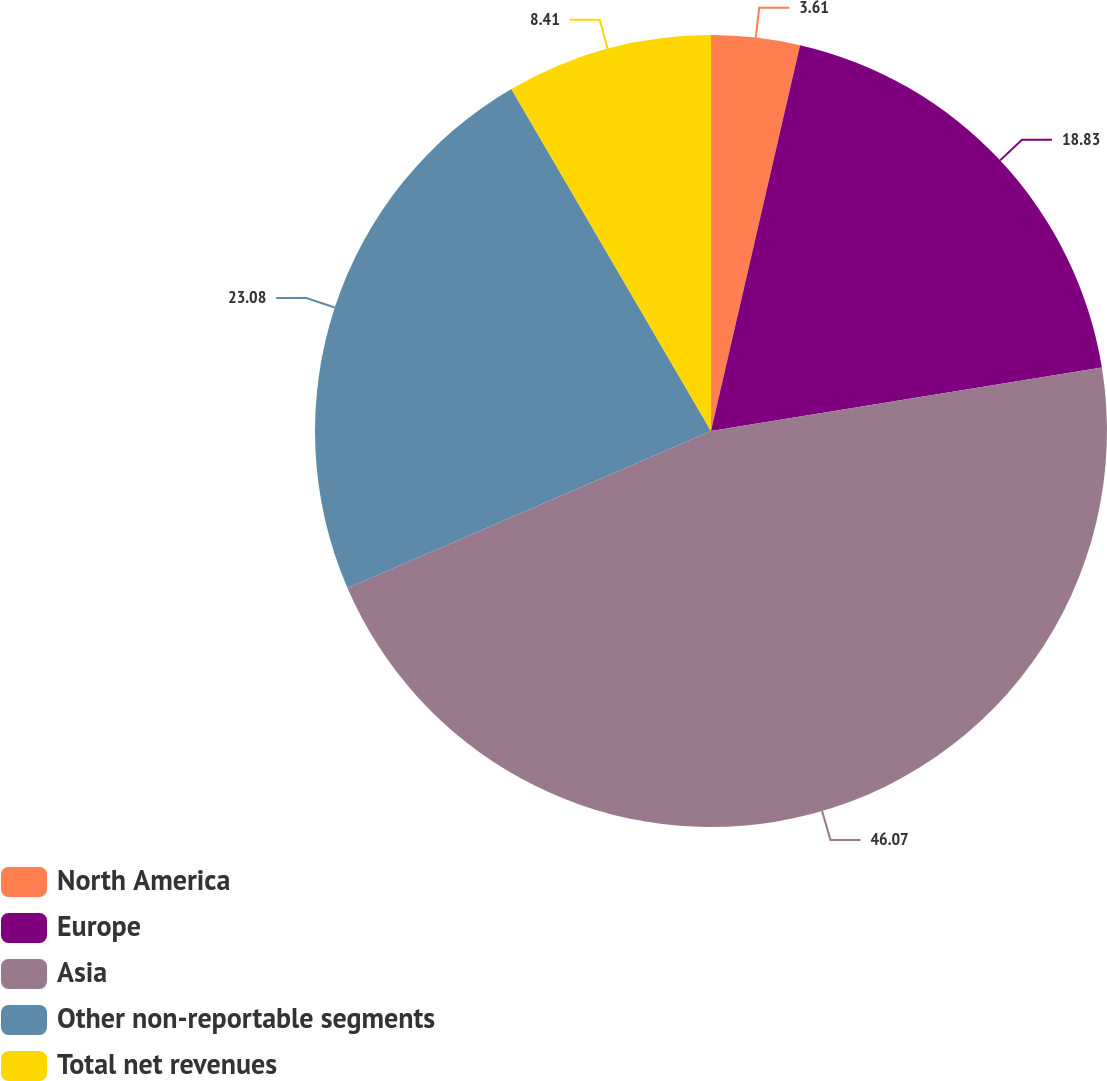Convert chart. <chart><loc_0><loc_0><loc_500><loc_500><pie_chart><fcel>North America<fcel>Europe<fcel>Asia<fcel>Other non-reportable segments<fcel>Total net revenues<nl><fcel>3.61%<fcel>18.83%<fcel>46.07%<fcel>23.08%<fcel>8.41%<nl></chart> 